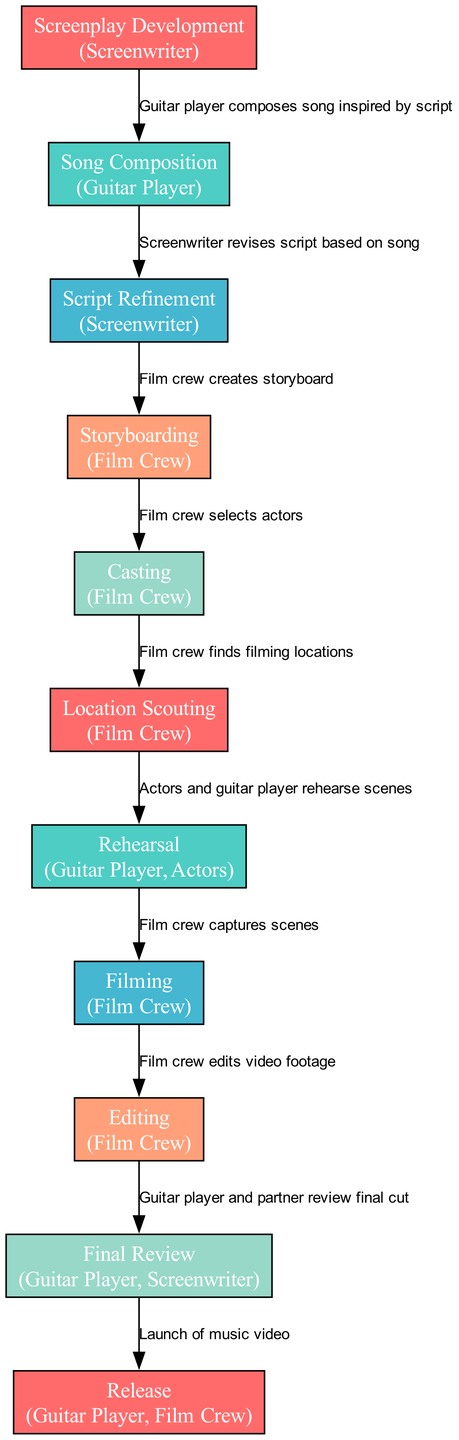What is the first action in the workflow? The first action is indicated by the first node in the diagram, which is "Partner writes preliminary script."
Answer: Partner writes preliminary script How many steps are there in the workflow? The number of steps can be counted by counting the nodes listed in the diagram, which total eleven.
Answer: 11 Who creates the storyboard? The role that creates the storyboard is specified in the corresponding node, which is the "Film Crew."
Answer: Film Crew What action follows "Song Composition"? The action that follows "Song Composition" is detailed in the edge leading to the next node, which is "Screenwriter revises script based on song."
Answer: Screenwriter revises script based on song Which actions involve both the Guitar Player and the Film Crew? By reviewing the nodes, the actions involving both parties are "Rehearsal" and "Release," as both roles are mentioned in their respective nodes.
Answer: Rehearsal, Release What is the last action in the workflow? The last action is the node that appears at the end of the sequence, which is "Launch of music video."
Answer: Launch of music video Which role is involved in both the "Final Review" and "Release"? The role that appears in both nodes is the "Guitar Player," indicating their involvement in these final stages.
Answer: Guitar Player What is the action taken after "Location Scouting"? The action taken after "Location Scouting" can be seen as the edge leading to the next node, which indicates "Actors and guitar player rehearse scenes."
Answer: Actors and guitar player rehearse scenes 